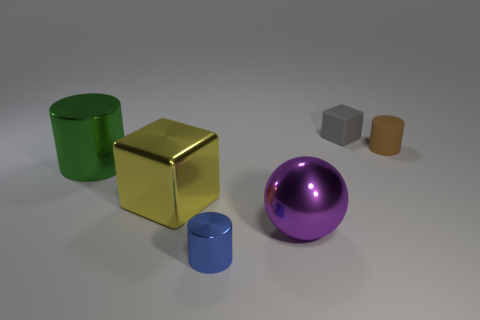Add 2 large purple objects. How many objects exist? 8 Subtract all spheres. How many objects are left? 5 Subtract all tiny blue metal cylinders. How many cylinders are left? 2 Subtract 1 balls. How many balls are left? 0 Subtract all yellow cylinders. Subtract all red balls. How many cylinders are left? 3 Subtract all purple cubes. How many purple cylinders are left? 0 Subtract all purple balls. Subtract all small blue matte cylinders. How many objects are left? 5 Add 2 tiny blue objects. How many tiny blue objects are left? 3 Add 5 green matte cylinders. How many green matte cylinders exist? 5 Subtract all brown cylinders. How many cylinders are left? 2 